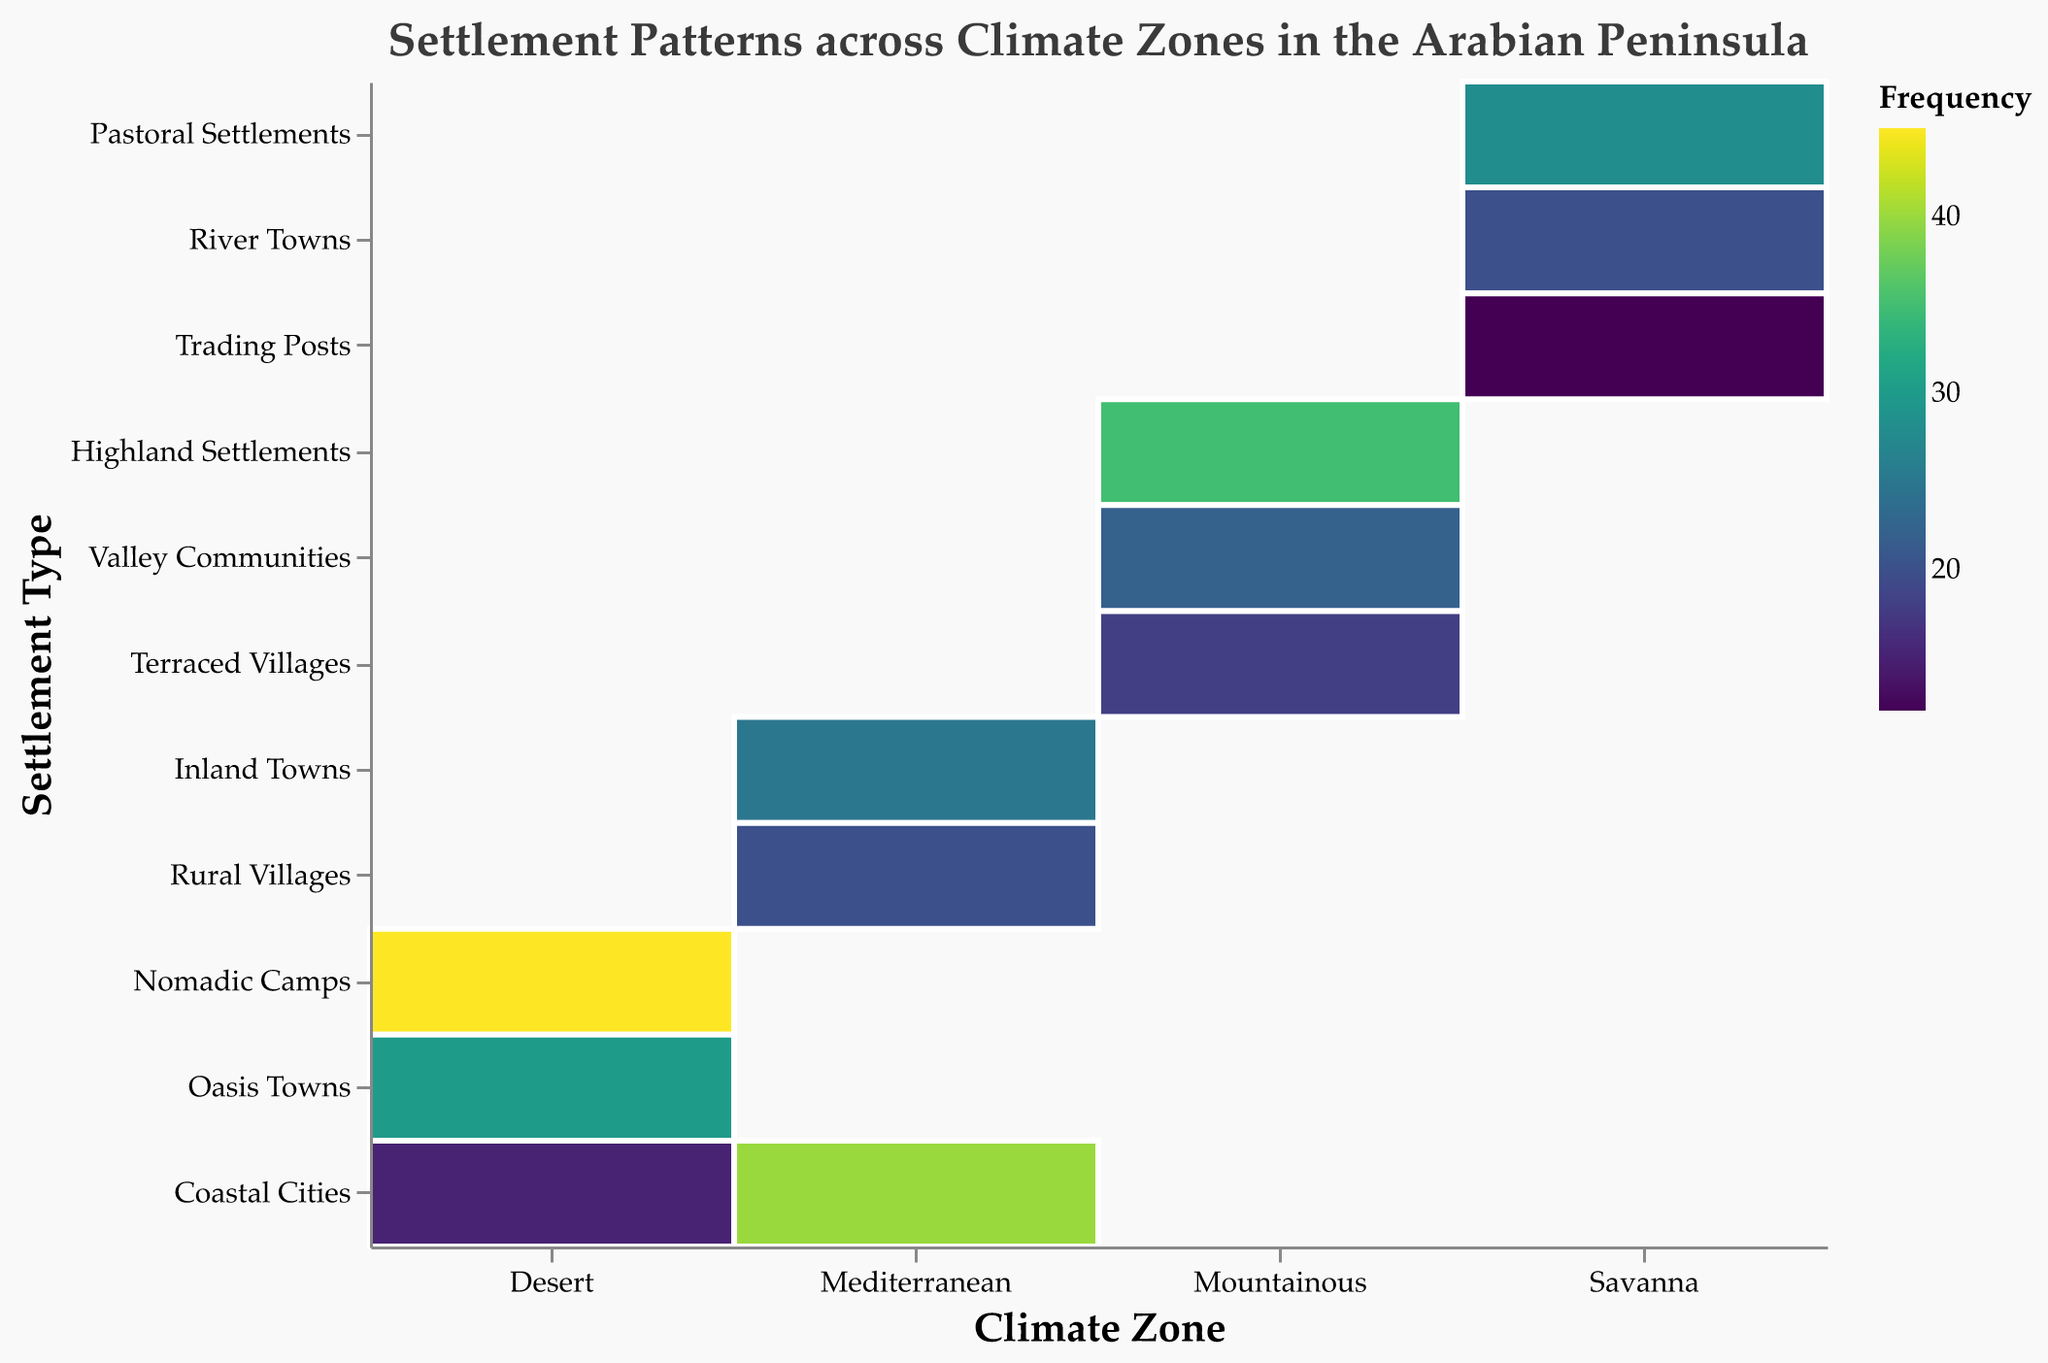What is the title of the figure? The title is usually found at the top of the figure and provides an overview of what the data represents. In this case, it indicates that the plot is about settlement patterns across different climate zones in the Arabian Peninsula.
Answer: Settlement Patterns across Climate Zones in the Arabian Peninsula Which climate zone has the highest frequency of settlements in Nomadic Camps? By looking at the color intensity in the Desert - Nomadic Camps area, it can be seen that this cell is the darkest within the plot. This indicates the highest frequency for Nomadic Camps within the Desert climate zone.
Answer: Desert Compare the total frequency of settlements in Desert and Mediterranean climate zones. Which one has more? To find this, sum up the frequencies of each settlement type within the Desert climate zone (45 + 30 + 15 = 90) and compare it to the sum of the frequencies within the Mediterranean climate zone (40 + 25 + 20 = 85). The Desert climate zone has a higher total frequency.
Answer: Desert Which settlement type appears most frequently within Mountainous climate zones? In the Mountainous zone, identify the darkest (most intense) cell. The Highland Settlements area is the darkest, indicating it has the highest frequency within the Mountainous zone.
Answer: Highland Settlements How does the frequency of Coastal Cities compare between Desert and Mediterranean climate zones? Compare the frequencies in the cells for Coastal Cities under Desert (15) and Mediterranean (40) climates. Mediterranean has a higher frequency than Desert.
Answer: Mediterranean has more What is the total frequency of settlements in the Savanna climate zone? Add up the frequencies of all settlement types within the Savanna zone: Pastoral Settlements (28), River Towns (20), and Trading Posts (12). The total is 28 + 20 + 12 = 60.
Answer: 60 Which climate zone has the most diverse types of settlements based on the number of different settlement types represented? Count the number of unique settlement types for each climate zone. Desert, Mediterranean, and Savanna each have three types, while Mountainous has three as well. The tie means there is no single most diverse zone.
Answer: Tie between Desert, Mediterranean, Mountainous, and Savanna What is the average frequency of settlements in the Mediterranean climate zone? Sum the frequencies for the Mediterranean climate zone (40, 25, 20) which is 85. Then divide this by the number of settlement types (3). So, the average frequency is 85 / 3 ≈ 28.33.
Answer: Approximately 28.33 